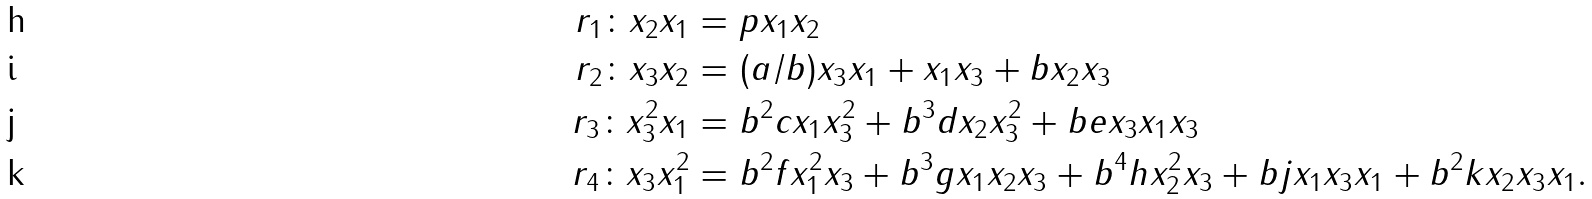<formula> <loc_0><loc_0><loc_500><loc_500>r _ { 1 } \colon x _ { 2 } x _ { 1 } & = p x _ { 1 } x _ { 2 } \\ r _ { 2 } \colon x _ { 3 } x _ { 2 } & = ( a / b ) x _ { 3 } x _ { 1 } + x _ { 1 } x _ { 3 } + b x _ { 2 } x _ { 3 } \\ r _ { 3 } \colon x _ { 3 } ^ { 2 } x _ { 1 } & = b ^ { 2 } c x _ { 1 } x _ { 3 } ^ { 2 } + b ^ { 3 } d x _ { 2 } x _ { 3 } ^ { 2 } + b e x _ { 3 } x _ { 1 } x _ { 3 } \\ r _ { 4 } \colon x _ { 3 } x _ { 1 } ^ { 2 } & = b ^ { 2 } f x _ { 1 } ^ { 2 } x _ { 3 } + b ^ { 3 } g x _ { 1 } x _ { 2 } x _ { 3 } + b ^ { 4 } h x _ { 2 } ^ { 2 } x _ { 3 } + b j x _ { 1 } x _ { 3 } x _ { 1 } + b ^ { 2 } k x _ { 2 } x _ { 3 } x _ { 1 } .</formula> 